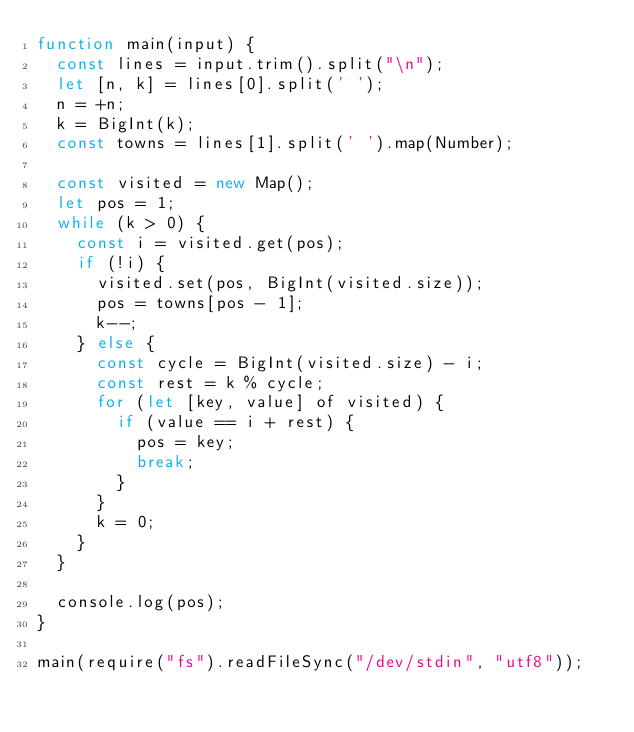Convert code to text. <code><loc_0><loc_0><loc_500><loc_500><_JavaScript_>function main(input) {
  const lines = input.trim().split("\n");
  let [n, k] = lines[0].split(' ');
  n = +n;
  k = BigInt(k);
  const towns = lines[1].split(' ').map(Number);

  const visited = new Map();
  let pos = 1;
  while (k > 0) {
    const i = visited.get(pos);
    if (!i) {
      visited.set(pos, BigInt(visited.size));
      pos = towns[pos - 1];
      k--;
    } else {
      const cycle = BigInt(visited.size) - i;
      const rest = k % cycle;
      for (let [key, value] of visited) {
        if (value == i + rest) {
          pos = key;
          break;
        }
      }
      k = 0;
    }
  }
  
  console.log(pos);
}

main(require("fs").readFileSync("/dev/stdin", "utf8"));</code> 